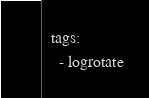Convert code to text. <code><loc_0><loc_0><loc_500><loc_500><_YAML_>  tags:
    - logrotate</code> 